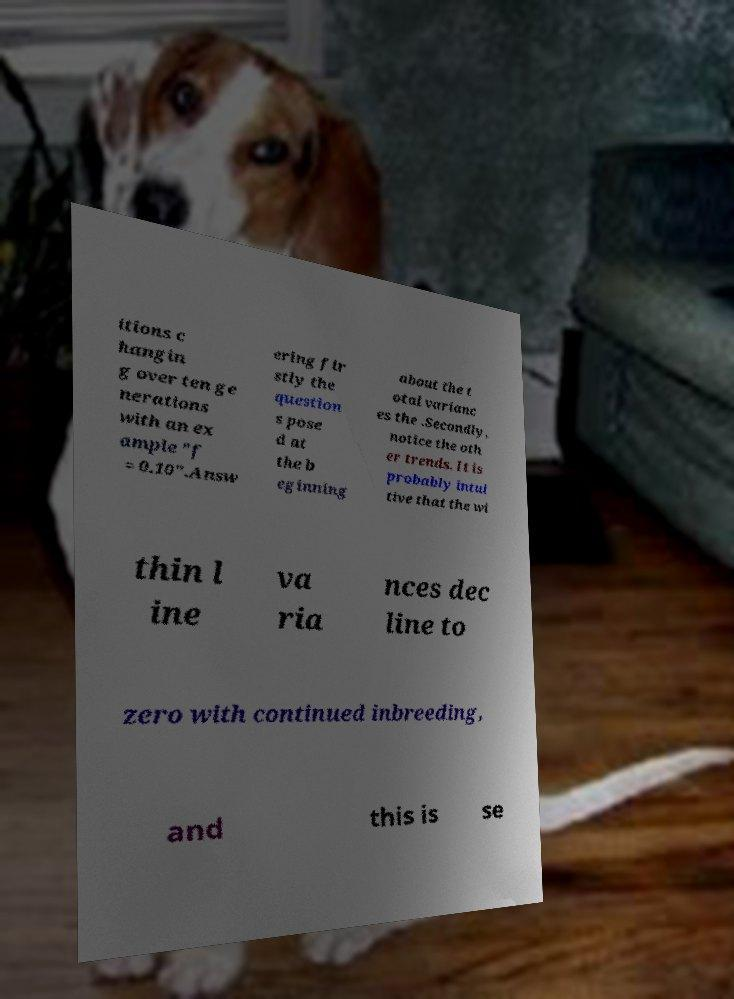I need the written content from this picture converted into text. Can you do that? itions c hangin g over ten ge nerations with an ex ample "f = 0.10".Answ ering fir stly the question s pose d at the b eginning about the t otal varianc es the .Secondly, notice the oth er trends. It is probably intui tive that the wi thin l ine va ria nces dec line to zero with continued inbreeding, and this is se 